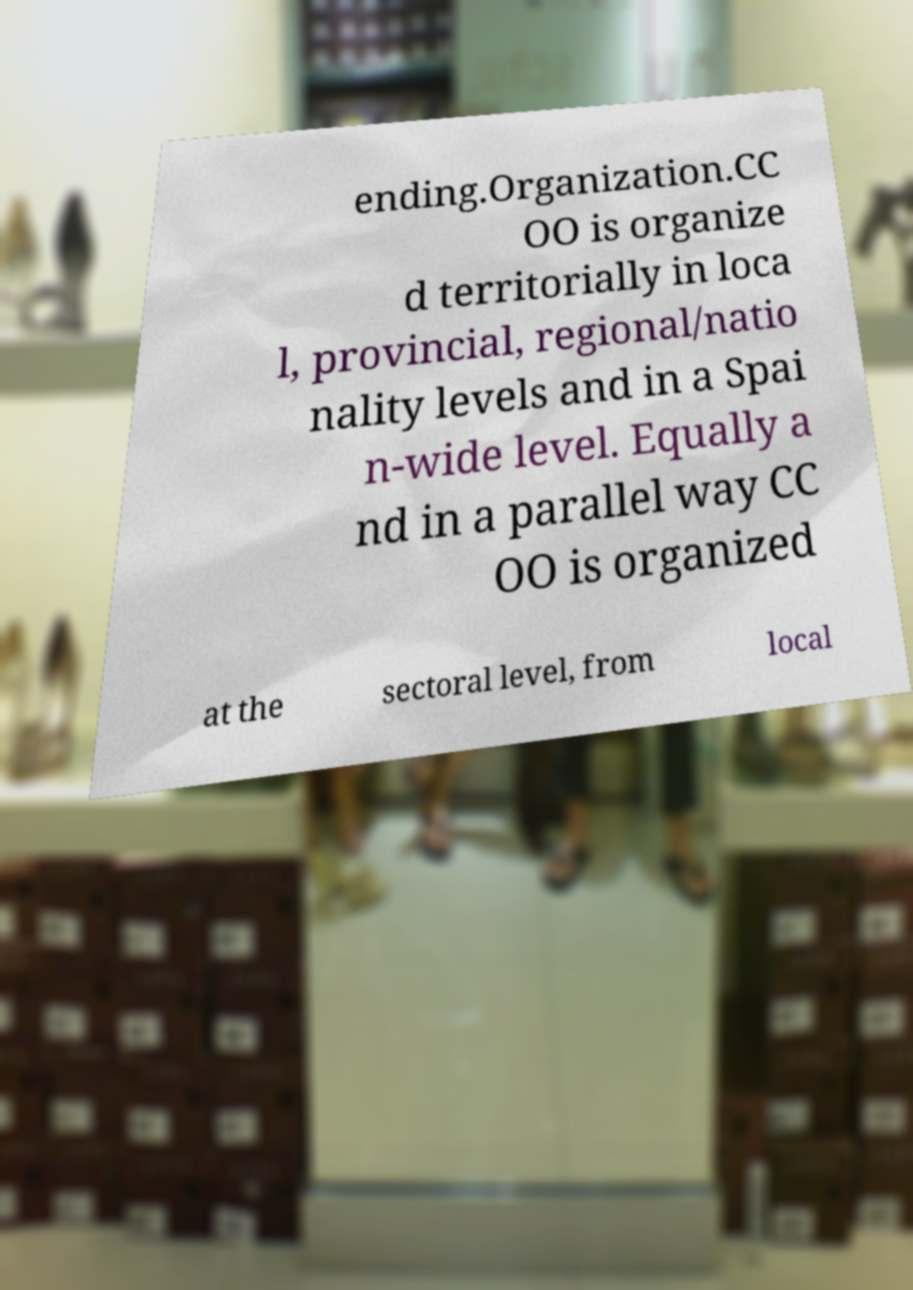Please read and relay the text visible in this image. What does it say? ending.Organization.CC OO is organize d territorially in loca l, provincial, regional/natio nality levels and in a Spai n-wide level. Equally a nd in a parallel way CC OO is organized at the sectoral level, from local 